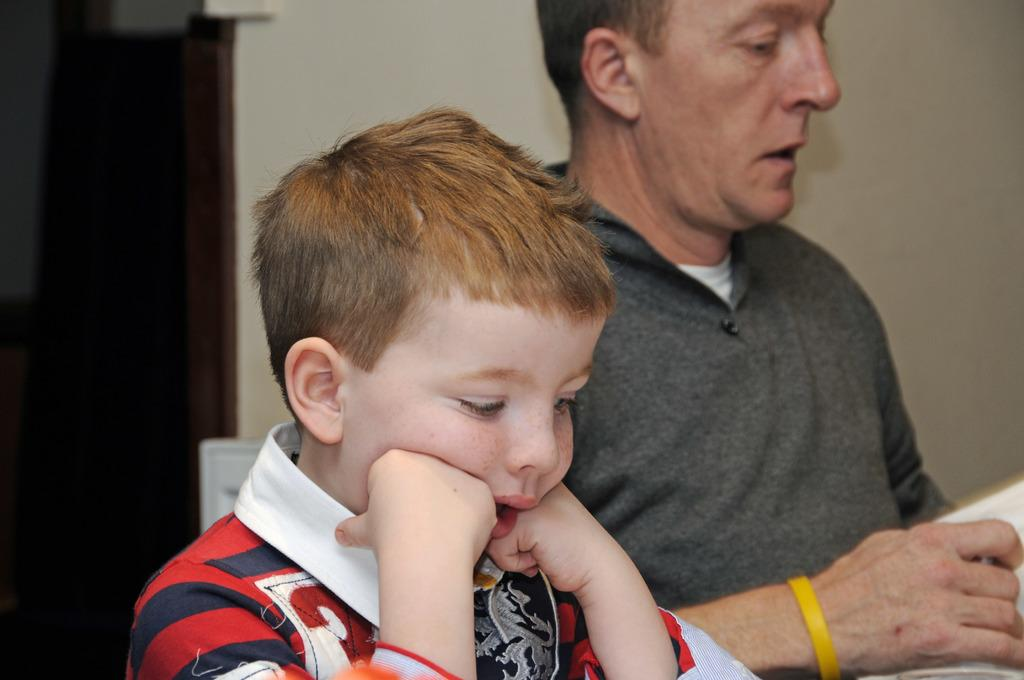Who is present in the image? There is a boy and a person in the image. What is the person holding in the image? The person is holding an object. What can be seen in the background of the image? There is a wall in the background of the image. How many frogs are sitting on the notebook in the image? There is no notebook or frogs present in the image. 